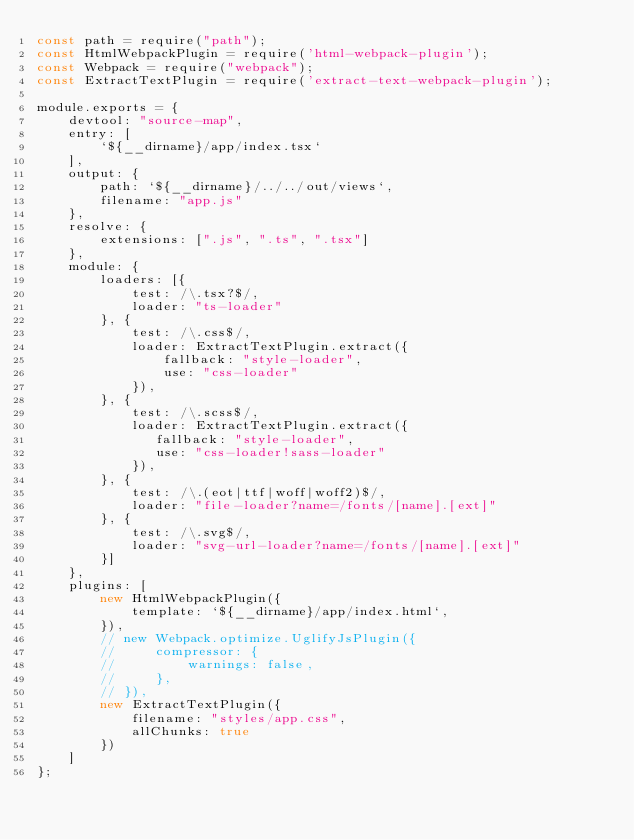Convert code to text. <code><loc_0><loc_0><loc_500><loc_500><_JavaScript_>const path = require("path");
const HtmlWebpackPlugin = require('html-webpack-plugin');
const Webpack = require("webpack");
const ExtractTextPlugin = require('extract-text-webpack-plugin');

module.exports = {
    devtool: "source-map",
    entry: [
        `${__dirname}/app/index.tsx`
    ],
    output: {
        path: `${__dirname}/../../out/views`,
        filename: "app.js"
    },
    resolve: {
        extensions: [".js", ".ts", ".tsx"]
    },
    module: {
        loaders: [{
            test: /\.tsx?$/,
            loader: "ts-loader"
        }, {
            test: /\.css$/,
            loader: ExtractTextPlugin.extract({
                fallback: "style-loader",
                use: "css-loader"
            }),
        }, {
            test: /\.scss$/,
            loader: ExtractTextPlugin.extract({
               fallback: "style-loader",
               use: "css-loader!sass-loader" 
            }),
        }, {
            test: /\.(eot|ttf|woff|woff2)$/,
            loader: "file-loader?name=/fonts/[name].[ext]"
        }, {
            test: /\.svg$/,
            loader: "svg-url-loader?name=/fonts/[name].[ext]"
        }]
    },
    plugins: [
        new HtmlWebpackPlugin({
            template: `${__dirname}/app/index.html`,
        }),
        // new Webpack.optimize.UglifyJsPlugin({
        //     compressor: {
        //         warnings: false,
        //     },
        // }),
        new ExtractTextPlugin({
            filename: "styles/app.css",
            allChunks: true
        })
    ]
};</code> 